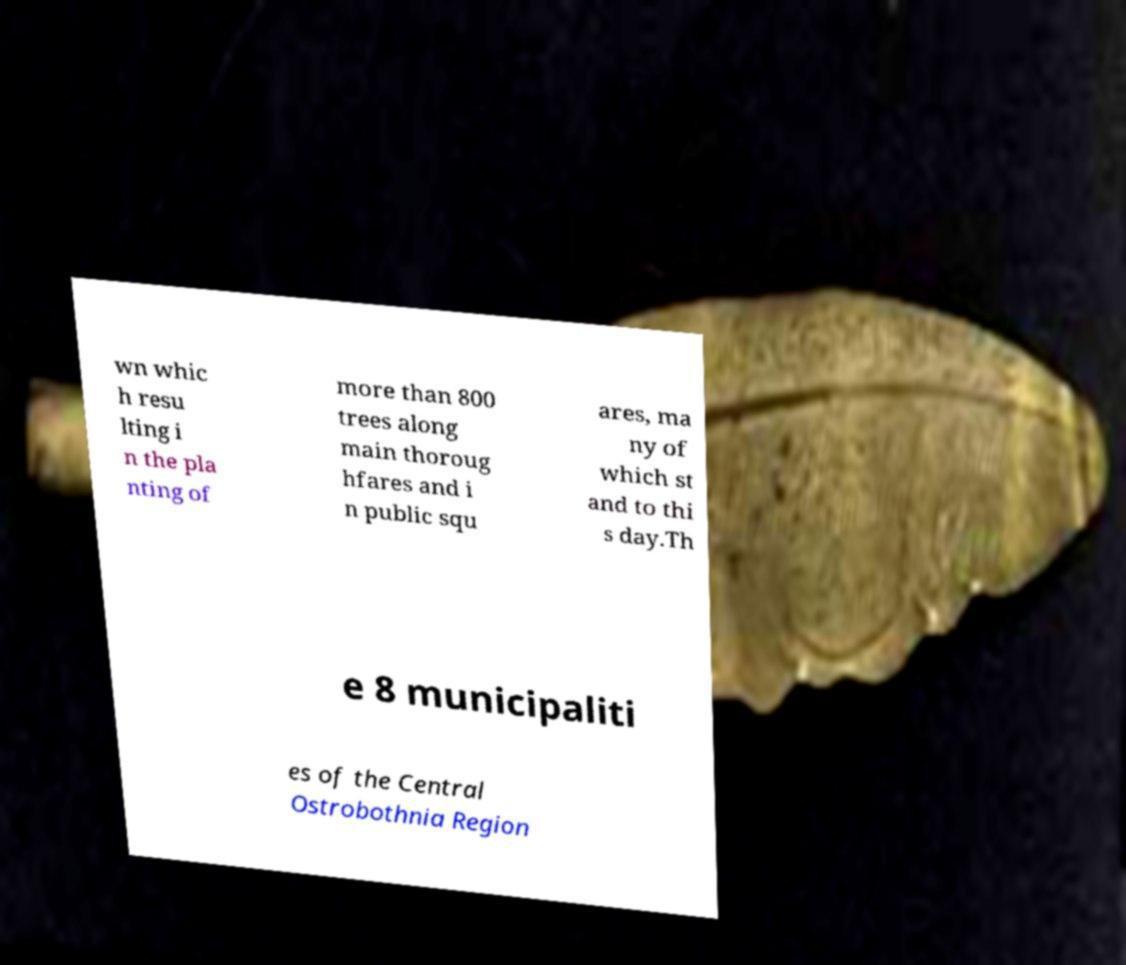Please read and relay the text visible in this image. What does it say? wn whic h resu lting i n the pla nting of more than 800 trees along main thoroug hfares and i n public squ ares, ma ny of which st and to thi s day.Th e 8 municipaliti es of the Central Ostrobothnia Region 